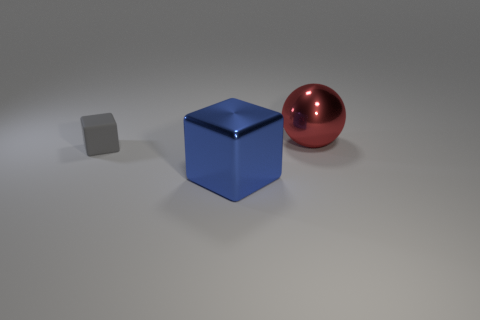Is there any other thing that is the same material as the tiny cube?
Your answer should be compact. No. There is a tiny gray thing; is its shape the same as the big thing that is in front of the small gray cube?
Provide a succinct answer. Yes. What material is the gray cube?
Your response must be concise. Rubber. There is a metal thing that is to the left of the large thing behind the block that is on the left side of the metallic cube; what is its color?
Provide a succinct answer. Blue. What is the material of the gray thing that is the same shape as the blue metallic object?
Keep it short and to the point. Rubber. What number of blue shiny cubes have the same size as the ball?
Your answer should be very brief. 1. How many big yellow objects are there?
Your response must be concise. 0. Do the small object and the large object that is on the left side of the large red object have the same material?
Your answer should be very brief. No. What number of purple things are either small things or big spheres?
Provide a succinct answer. 0. What is the size of the sphere that is the same material as the large blue block?
Provide a succinct answer. Large. 